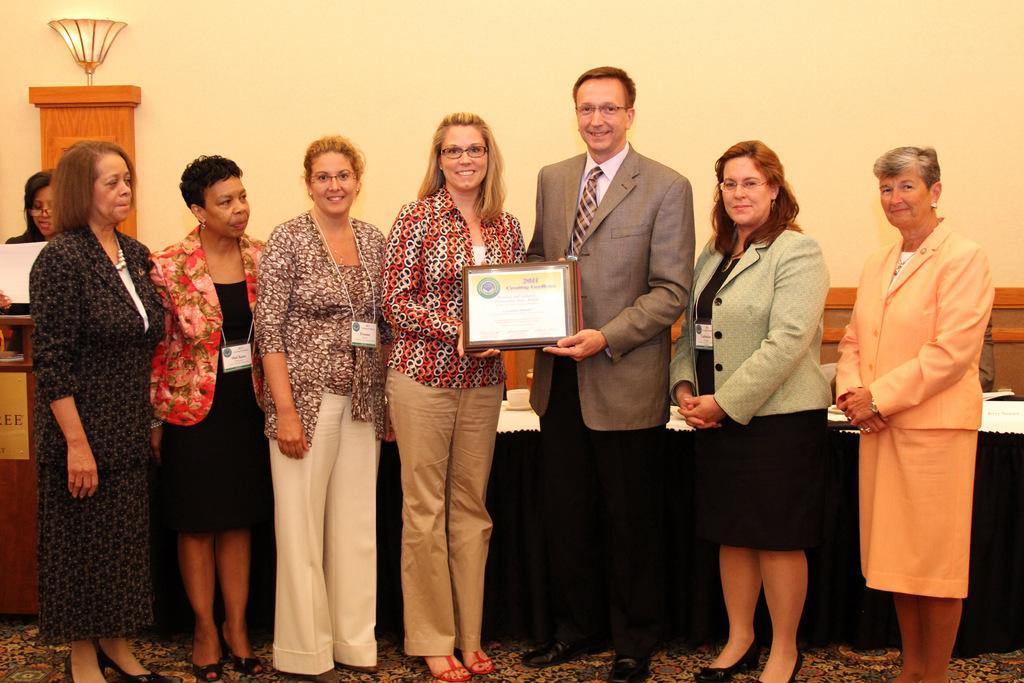Can you describe this image briefly? In this image I can see group of people standing. The person in front holding a certificate and the person is wearing brown blazer, white shirt and black pant. Background I can see a light pole, and wall in cream color. 